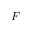Convert formula to latex. <formula><loc_0><loc_0><loc_500><loc_500>F</formula> 